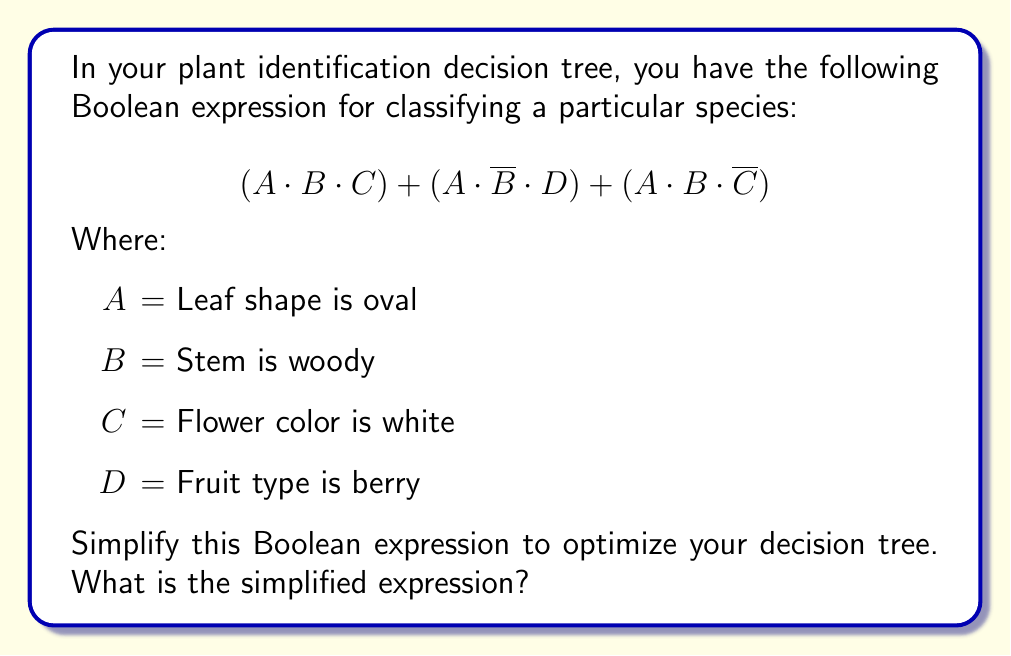Teach me how to tackle this problem. Let's simplify this Boolean expression step by step using Boolean algebra laws:

1) First, we can factor out A, which is common to all terms:
   $A \cdot [(B \cdot C) + (\overline{B} \cdot D) + (B \cdot \overline{C})]$

2) Now, let's focus on the expression inside the brackets:
   $(B \cdot C) + (\overline{B} \cdot D) + (B \cdot \overline{C})$

3) We can apply the distributive law to the last two terms:
   $(B \cdot C) + (\overline{B} \cdot D) + (B \cdot 1 \cdot \overline{C})$

4) Now we can use the identity $X + (X \cdot Y) = X$ on the first and third terms:
   $B \cdot (C + \overline{C}) + (\overline{B} \cdot D)$

5) Simplify using the law of complements $(C + \overline{C} = 1)$:
   $B \cdot 1 + (\overline{B} \cdot D)$

6) Simplify further:
   $B + (\overline{B} \cdot D)$

7) Finally, we can put this back into our original expression with A:
   $A \cdot [B + (\overline{B} \cdot D)]$

This is our simplified Boolean expression.
Answer: $A \cdot [B + (\overline{B} \cdot D)]$ 